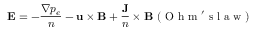Convert formula to latex. <formula><loc_0><loc_0><loc_500><loc_500>{ \mathbf E } = - \frac { \nabla p _ { e } } { n } - { \mathbf u } \times { \mathbf B } + \frac { \mathbf J } { n } \times { \mathbf B } \ ( O h m ^ { \prime } s l a w )</formula> 